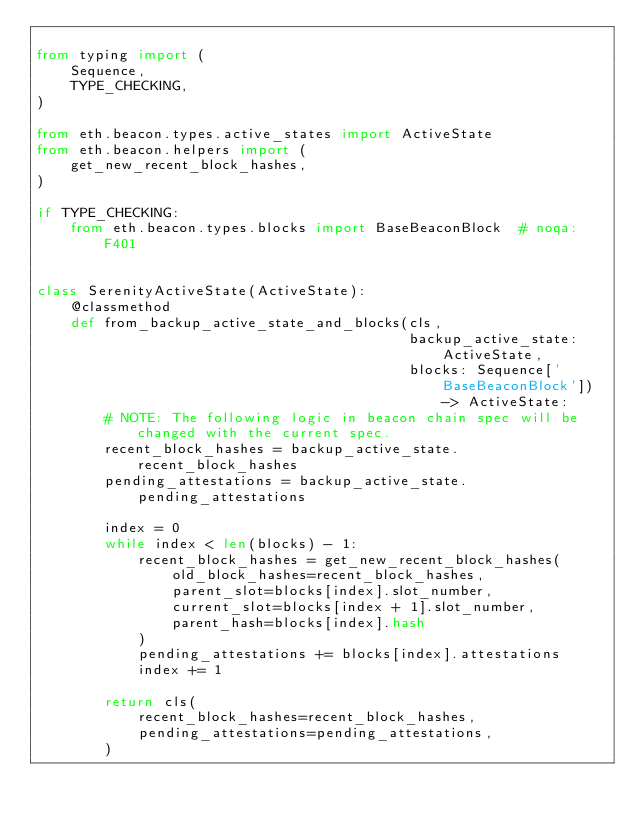<code> <loc_0><loc_0><loc_500><loc_500><_Python_>
from typing import (
    Sequence,
    TYPE_CHECKING,
)

from eth.beacon.types.active_states import ActiveState
from eth.beacon.helpers import (
    get_new_recent_block_hashes,
)

if TYPE_CHECKING:
    from eth.beacon.types.blocks import BaseBeaconBlock  # noqa: F401


class SerenityActiveState(ActiveState):
    @classmethod
    def from_backup_active_state_and_blocks(cls,
                                            backup_active_state: ActiveState,
                                            blocks: Sequence['BaseBeaconBlock']) -> ActiveState:
        # NOTE: The following logic in beacon chain spec will be changed with the current spec.
        recent_block_hashes = backup_active_state.recent_block_hashes
        pending_attestations = backup_active_state.pending_attestations

        index = 0
        while index < len(blocks) - 1:
            recent_block_hashes = get_new_recent_block_hashes(
                old_block_hashes=recent_block_hashes,
                parent_slot=blocks[index].slot_number,
                current_slot=blocks[index + 1].slot_number,
                parent_hash=blocks[index].hash
            )
            pending_attestations += blocks[index].attestations
            index += 1

        return cls(
            recent_block_hashes=recent_block_hashes,
            pending_attestations=pending_attestations,
        )
</code> 